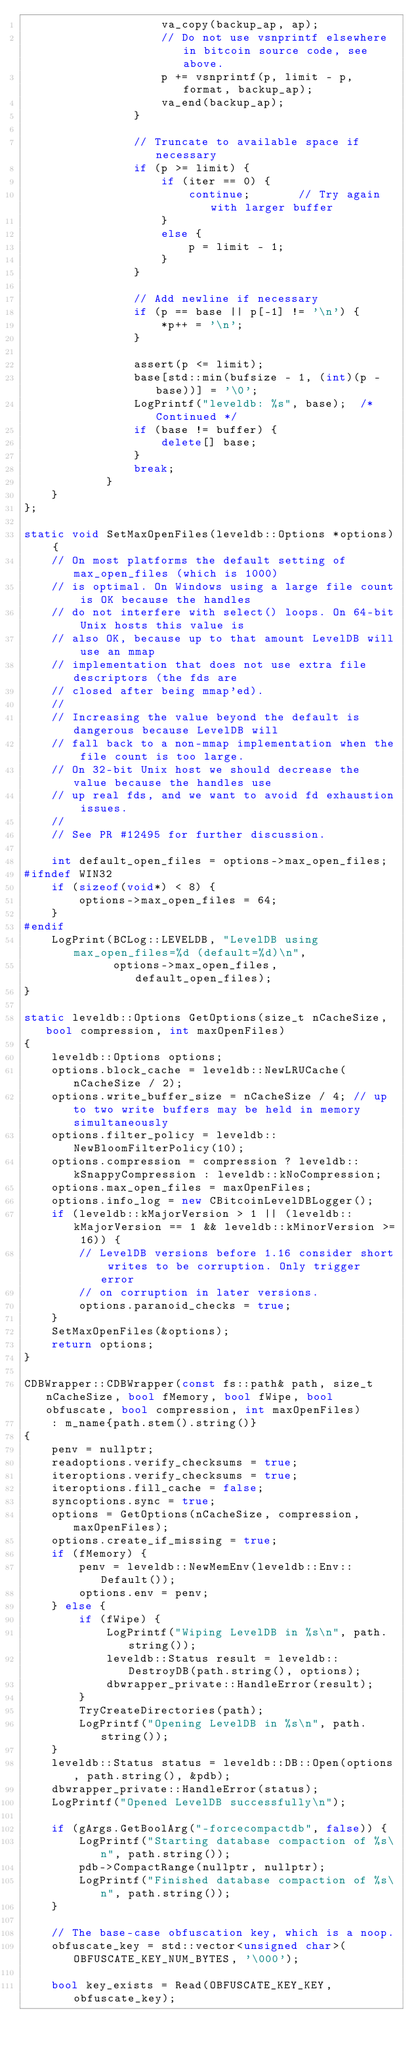<code> <loc_0><loc_0><loc_500><loc_500><_C++_>                    va_copy(backup_ap, ap);
                    // Do not use vsnprintf elsewhere in bitcoin source code, see above.
                    p += vsnprintf(p, limit - p, format, backup_ap);
                    va_end(backup_ap);
                }

                // Truncate to available space if necessary
                if (p >= limit) {
                    if (iter == 0) {
                        continue;       // Try again with larger buffer
                    }
                    else {
                        p = limit - 1;
                    }
                }

                // Add newline if necessary
                if (p == base || p[-1] != '\n') {
                    *p++ = '\n';
                }

                assert(p <= limit);
                base[std::min(bufsize - 1, (int)(p - base))] = '\0';
                LogPrintf("leveldb: %s", base);  /* Continued */
                if (base != buffer) {
                    delete[] base;
                }
                break;
            }
    }
};

static void SetMaxOpenFiles(leveldb::Options *options) {
    // On most platforms the default setting of max_open_files (which is 1000)
    // is optimal. On Windows using a large file count is OK because the handles
    // do not interfere with select() loops. On 64-bit Unix hosts this value is
    // also OK, because up to that amount LevelDB will use an mmap
    // implementation that does not use extra file descriptors (the fds are
    // closed after being mmap'ed).
    //
    // Increasing the value beyond the default is dangerous because LevelDB will
    // fall back to a non-mmap implementation when the file count is too large.
    // On 32-bit Unix host we should decrease the value because the handles use
    // up real fds, and we want to avoid fd exhaustion issues.
    //
    // See PR #12495 for further discussion.

    int default_open_files = options->max_open_files;
#ifndef WIN32
    if (sizeof(void*) < 8) {
        options->max_open_files = 64;
    }
#endif
    LogPrint(BCLog::LEVELDB, "LevelDB using max_open_files=%d (default=%d)\n",
             options->max_open_files, default_open_files);
}

static leveldb::Options GetOptions(size_t nCacheSize, bool compression, int maxOpenFiles)
{
    leveldb::Options options;
    options.block_cache = leveldb::NewLRUCache(nCacheSize / 2);
    options.write_buffer_size = nCacheSize / 4; // up to two write buffers may be held in memory simultaneously
    options.filter_policy = leveldb::NewBloomFilterPolicy(10);
    options.compression = compression ? leveldb::kSnappyCompression : leveldb::kNoCompression;
    options.max_open_files = maxOpenFiles;
    options.info_log = new CBitcoinLevelDBLogger();
    if (leveldb::kMajorVersion > 1 || (leveldb::kMajorVersion == 1 && leveldb::kMinorVersion >= 16)) {
        // LevelDB versions before 1.16 consider short writes to be corruption. Only trigger error
        // on corruption in later versions.
        options.paranoid_checks = true;
    }
    SetMaxOpenFiles(&options);
    return options;
}

CDBWrapper::CDBWrapper(const fs::path& path, size_t nCacheSize, bool fMemory, bool fWipe, bool obfuscate, bool compression, int maxOpenFiles)
    : m_name{path.stem().string()}
{
    penv = nullptr;
    readoptions.verify_checksums = true;
    iteroptions.verify_checksums = true;
    iteroptions.fill_cache = false;
    syncoptions.sync = true;
    options = GetOptions(nCacheSize, compression, maxOpenFiles);
    options.create_if_missing = true;
    if (fMemory) {
        penv = leveldb::NewMemEnv(leveldb::Env::Default());
        options.env = penv;
    } else {
        if (fWipe) {
            LogPrintf("Wiping LevelDB in %s\n", path.string());
            leveldb::Status result = leveldb::DestroyDB(path.string(), options);
            dbwrapper_private::HandleError(result);
        }
        TryCreateDirectories(path);
        LogPrintf("Opening LevelDB in %s\n", path.string());
    }
    leveldb::Status status = leveldb::DB::Open(options, path.string(), &pdb);
    dbwrapper_private::HandleError(status);
    LogPrintf("Opened LevelDB successfully\n");

    if (gArgs.GetBoolArg("-forcecompactdb", false)) {
        LogPrintf("Starting database compaction of %s\n", path.string());
        pdb->CompactRange(nullptr, nullptr);
        LogPrintf("Finished database compaction of %s\n", path.string());
    }

    // The base-case obfuscation key, which is a noop.
    obfuscate_key = std::vector<unsigned char>(OBFUSCATE_KEY_NUM_BYTES, '\000');

    bool key_exists = Read(OBFUSCATE_KEY_KEY, obfuscate_key);
</code> 